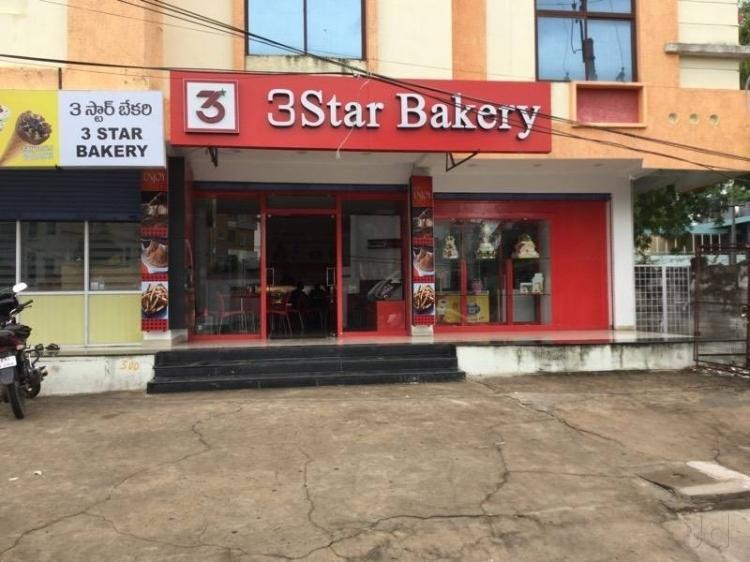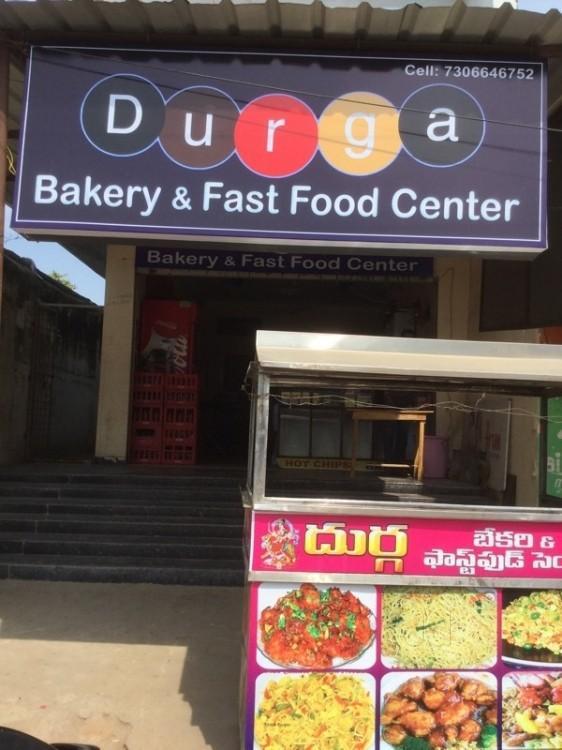The first image is the image on the left, the second image is the image on the right. Analyze the images presented: Is the assertion "there is a bakery with a star shape on their sign and black framed windows" valid? Answer yes or no. No. 